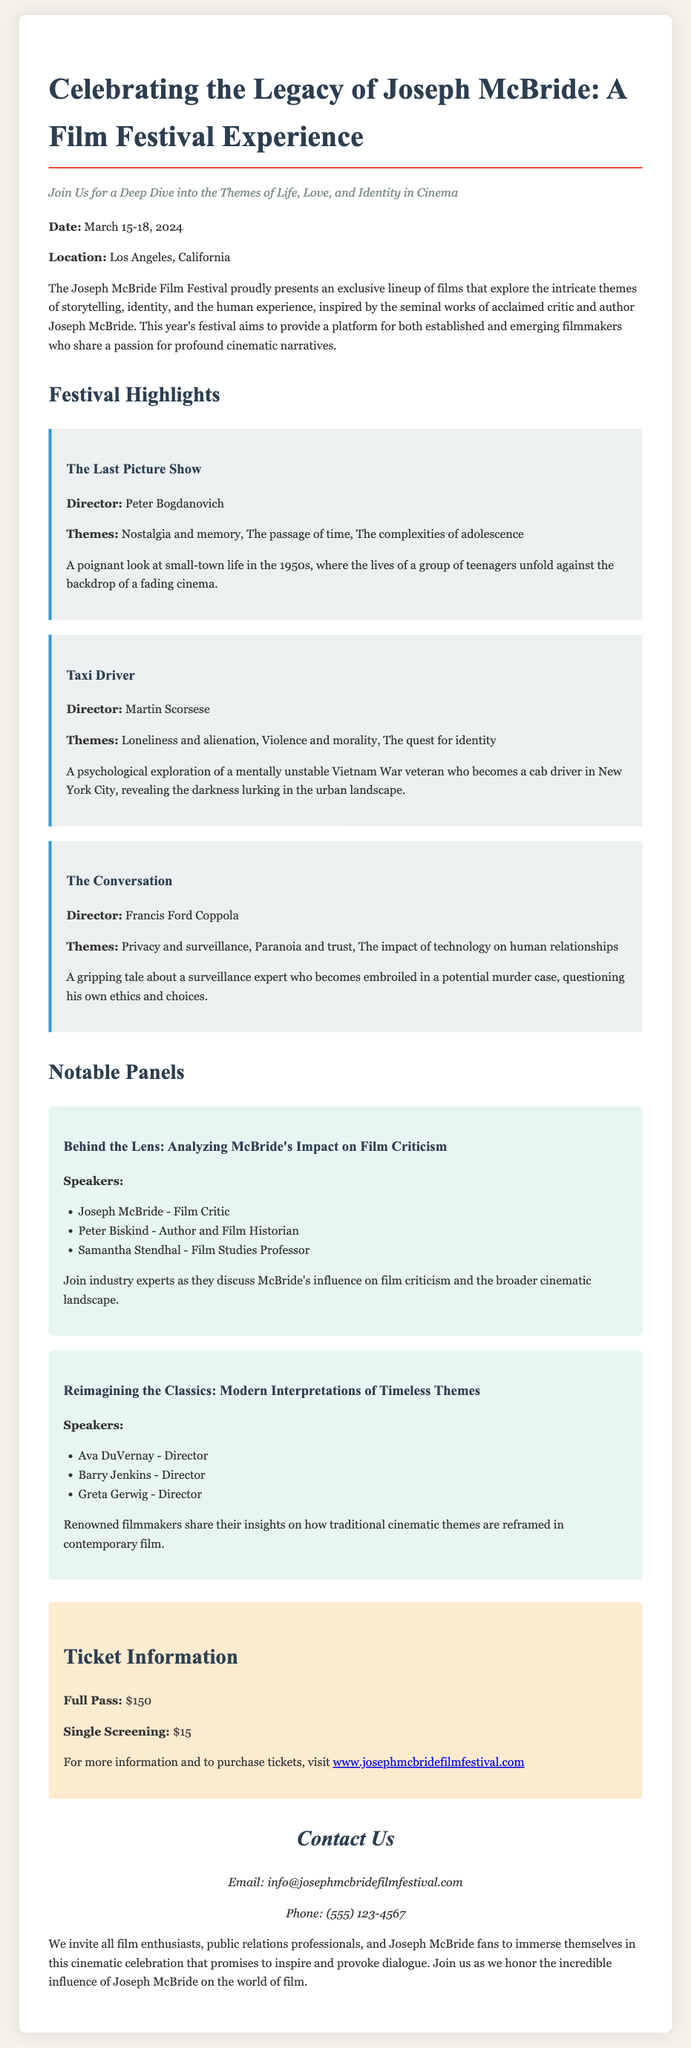What are the dates of the film festival? The festival is scheduled to occur from March 15 to March 18, 2024.
Answer: March 15-18, 2024 Where is the Joseph McBride Film Festival taking place? The location mentioned in the document is Los Angeles, California.
Answer: Los Angeles, California Who directed "Taxi Driver"? The document specifies Martin Scorsese as the director of "Taxi Driver".
Answer: Martin Scorsese What is the price of a full pass? The full pass is priced at $150 as stated in the ticket information section.
Answer: $150 What themes are explored in "The Conversation"? The themes listed for "The Conversation" include privacy and surveillance, paranoia and trust, and the impact of technology on human relationships.
Answer: Privacy and surveillance, paranoia and trust, the impact of technology on human relationships Who are the speakers in the panel "Reimagining the Classics"? The document lists Ava DuVernay, Barry Jenkins, and Greta Gerwig as the speakers for this panel.
Answer: Ava DuVernay, Barry Jenkins, Greta Gerwig What does the subtitle emphasize about the festival experience? The subtitle highlights the festival's focus on exploring themes of life, love, and identity in cinema.
Answer: Life, love, and identity in cinema What does the festival aim to provide a platform for? The festival seeks to provide a platform for established and emerging filmmakers.
Answer: Established and emerging filmmakers What is the official website for purchasing tickets? The document provides a website URL for more information and ticket purchases.
Answer: www.josephmcbridefilmfestival.com 